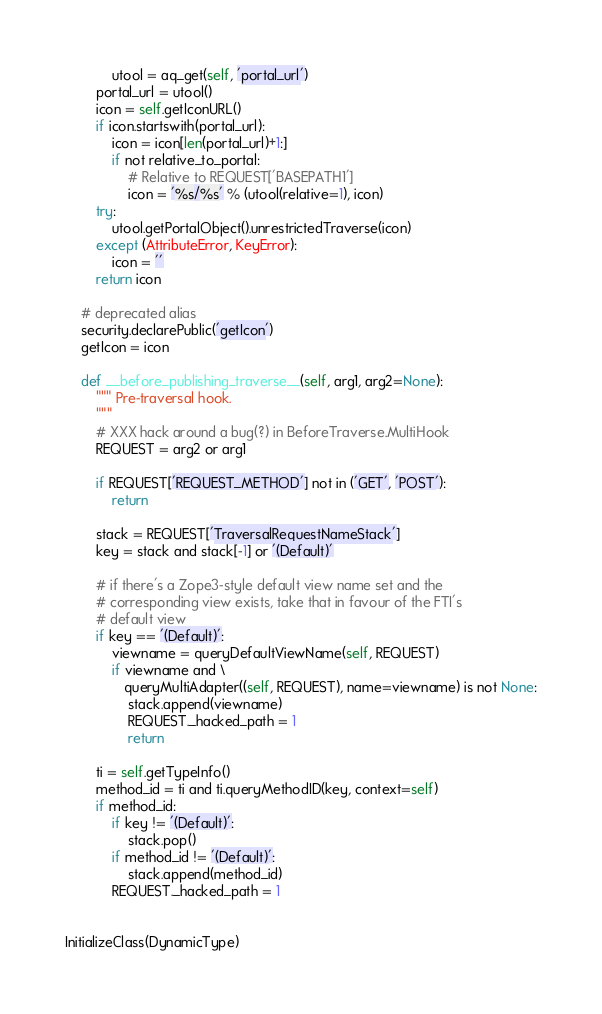<code> <loc_0><loc_0><loc_500><loc_500><_Python_>            utool = aq_get(self, 'portal_url')
        portal_url = utool()
        icon = self.getIconURL()
        if icon.startswith(portal_url):
            icon = icon[len(portal_url)+1:]
            if not relative_to_portal:
                # Relative to REQUEST['BASEPATH1']
                icon = '%s/%s' % (utool(relative=1), icon)
        try:
            utool.getPortalObject().unrestrictedTraverse(icon)
        except (AttributeError, KeyError):
            icon = ''
        return icon

    # deprecated alias
    security.declarePublic('getIcon')
    getIcon = icon

    def __before_publishing_traverse__(self, arg1, arg2=None):
        """ Pre-traversal hook.
        """
        # XXX hack around a bug(?) in BeforeTraverse.MultiHook
        REQUEST = arg2 or arg1

        if REQUEST['REQUEST_METHOD'] not in ('GET', 'POST'):
            return

        stack = REQUEST['TraversalRequestNameStack']
        key = stack and stack[-1] or '(Default)'

        # if there's a Zope3-style default view name set and the
        # corresponding view exists, take that in favour of the FTI's
        # default view
        if key == '(Default)':
            viewname = queryDefaultViewName(self, REQUEST)
            if viewname and \
               queryMultiAdapter((self, REQUEST), name=viewname) is not None:
                stack.append(viewname)
                REQUEST._hacked_path = 1
                return

        ti = self.getTypeInfo()
        method_id = ti and ti.queryMethodID(key, context=self)
        if method_id:
            if key != '(Default)':
                stack.pop()
            if method_id != '(Default)':
                stack.append(method_id)
            REQUEST._hacked_path = 1


InitializeClass(DynamicType)
</code> 